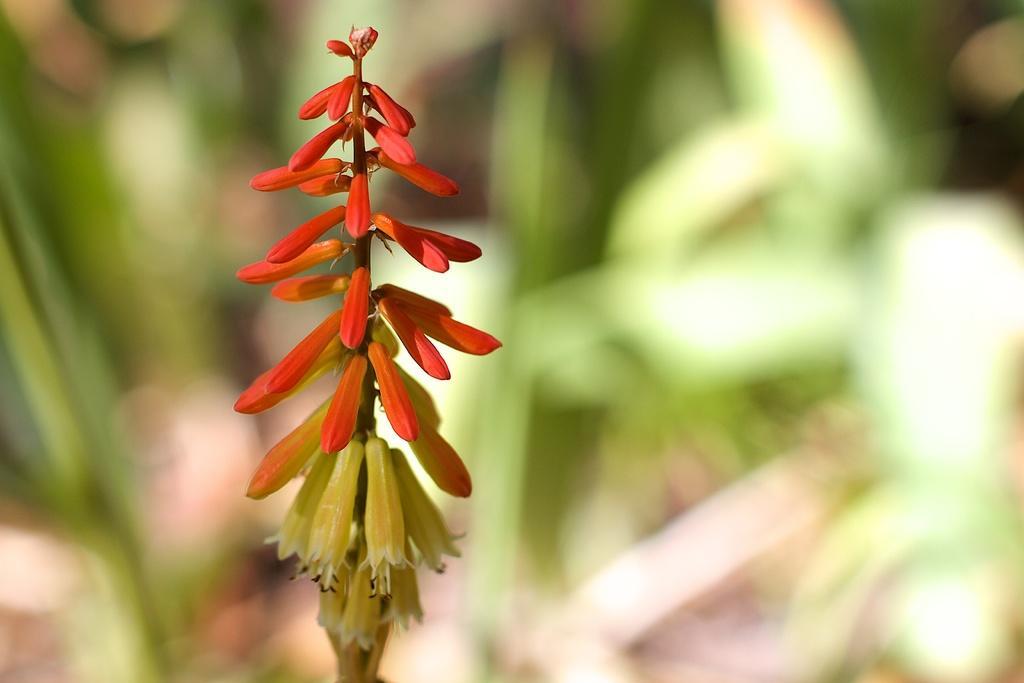Could you give a brief overview of what you see in this image? In this image, we can see flowers with stem. Background there is a blur view. Here we can see green color. 